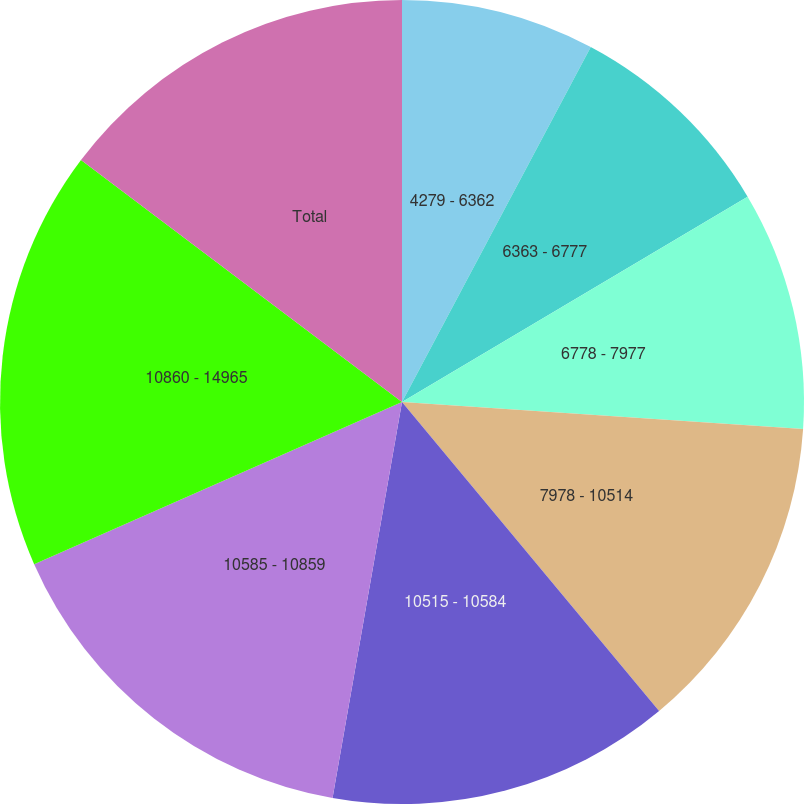Convert chart. <chart><loc_0><loc_0><loc_500><loc_500><pie_chart><fcel>4279 - 6362<fcel>6363 - 6777<fcel>6778 - 7977<fcel>7978 - 10514<fcel>10515 - 10584<fcel>10585 - 10859<fcel>10860 - 14965<fcel>Total<nl><fcel>7.78%<fcel>8.69%<fcel>9.6%<fcel>12.89%<fcel>13.81%<fcel>15.63%<fcel>16.89%<fcel>14.72%<nl></chart> 